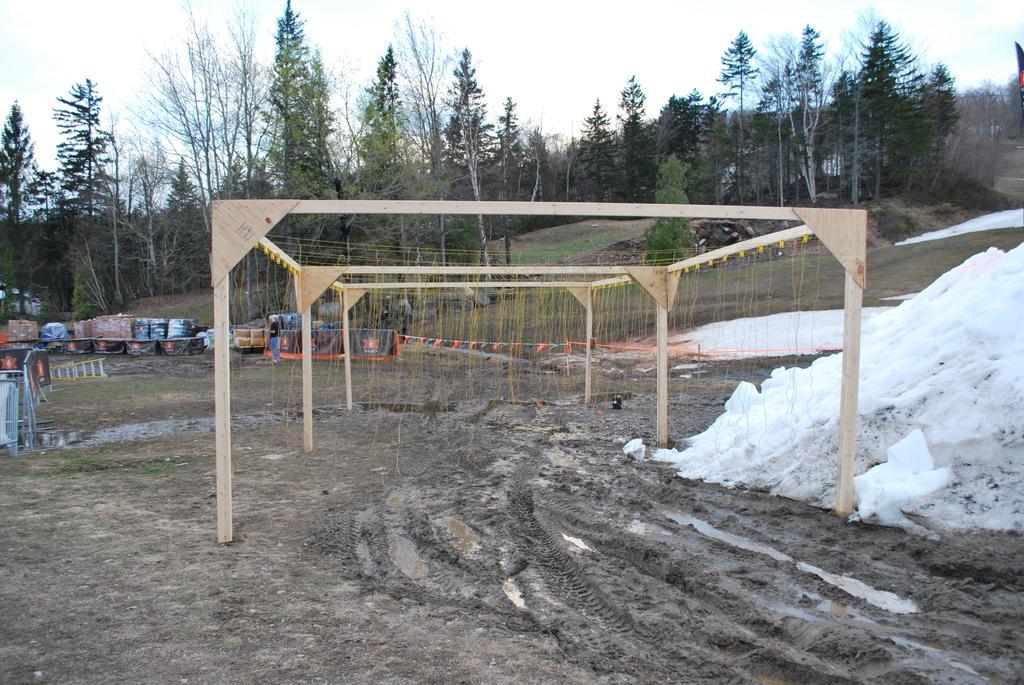Could you give a brief overview of what you see in this image? This picture is clicked outside. In the center we can see the wooden poles and we can see the boxes and many other objects are placed on the ground. On the right corner there is a white color object which seems to be the snow. In the background we can see the sky, trees and some other objects. 